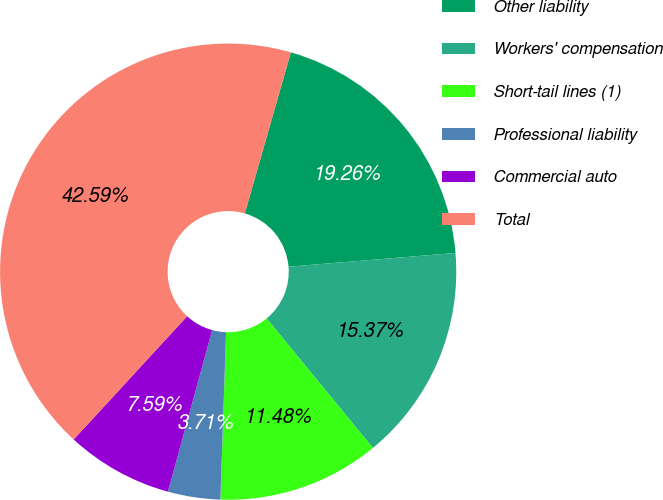Convert chart to OTSL. <chart><loc_0><loc_0><loc_500><loc_500><pie_chart><fcel>Other liability<fcel>Workers' compensation<fcel>Short-tail lines (1)<fcel>Professional liability<fcel>Commercial auto<fcel>Total<nl><fcel>19.26%<fcel>15.37%<fcel>11.48%<fcel>3.71%<fcel>7.59%<fcel>42.59%<nl></chart> 